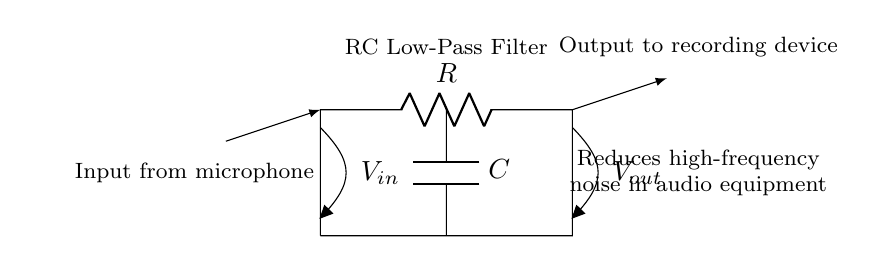What type of filter is represented in this circuit? The circuit is labeled as an "RC Low-Pass Filter," indicating that it is designed to allow low-frequency signals to pass while attenuating high-frequency noise.
Answer: RC Low-Pass Filter What are the components used in this circuit? The circuit consists of a resistor and a capacitor, which are essential for the low-pass filtering operation by forming an RC network.
Answer: Resistor and Capacitor What is the function of the capacitor in this circuit? The capacitor stores and releases electrical energy, contributing to the filtering action by shunting high-frequency noise away from the output.
Answer: To filter high-frequency noise What is the input source for this circuit? The diagram indicates that the input source comes from a microphone, which is typical in audio recording applications to capture sound.
Answer: Microphone What signal is expected at the output of this filter? The output signal should represent the clean audio signal with reduced high-frequency noise, suitable for further processing or recording.
Answer: Clean audio signal How does the resistor affect the frequency response? The resistor defines the time constant of the filter along with the capacitor, which determines the cutoff frequency, controlling which frequencies are attenuated.
Answer: It determines the cutoff frequency What happens to high-frequency signals in this circuit? High-frequency signals are attenuated or reduced in amplitude as they pass through the filter, allowing only lower frequencies to pass through to the output.
Answer: They are attenuated 